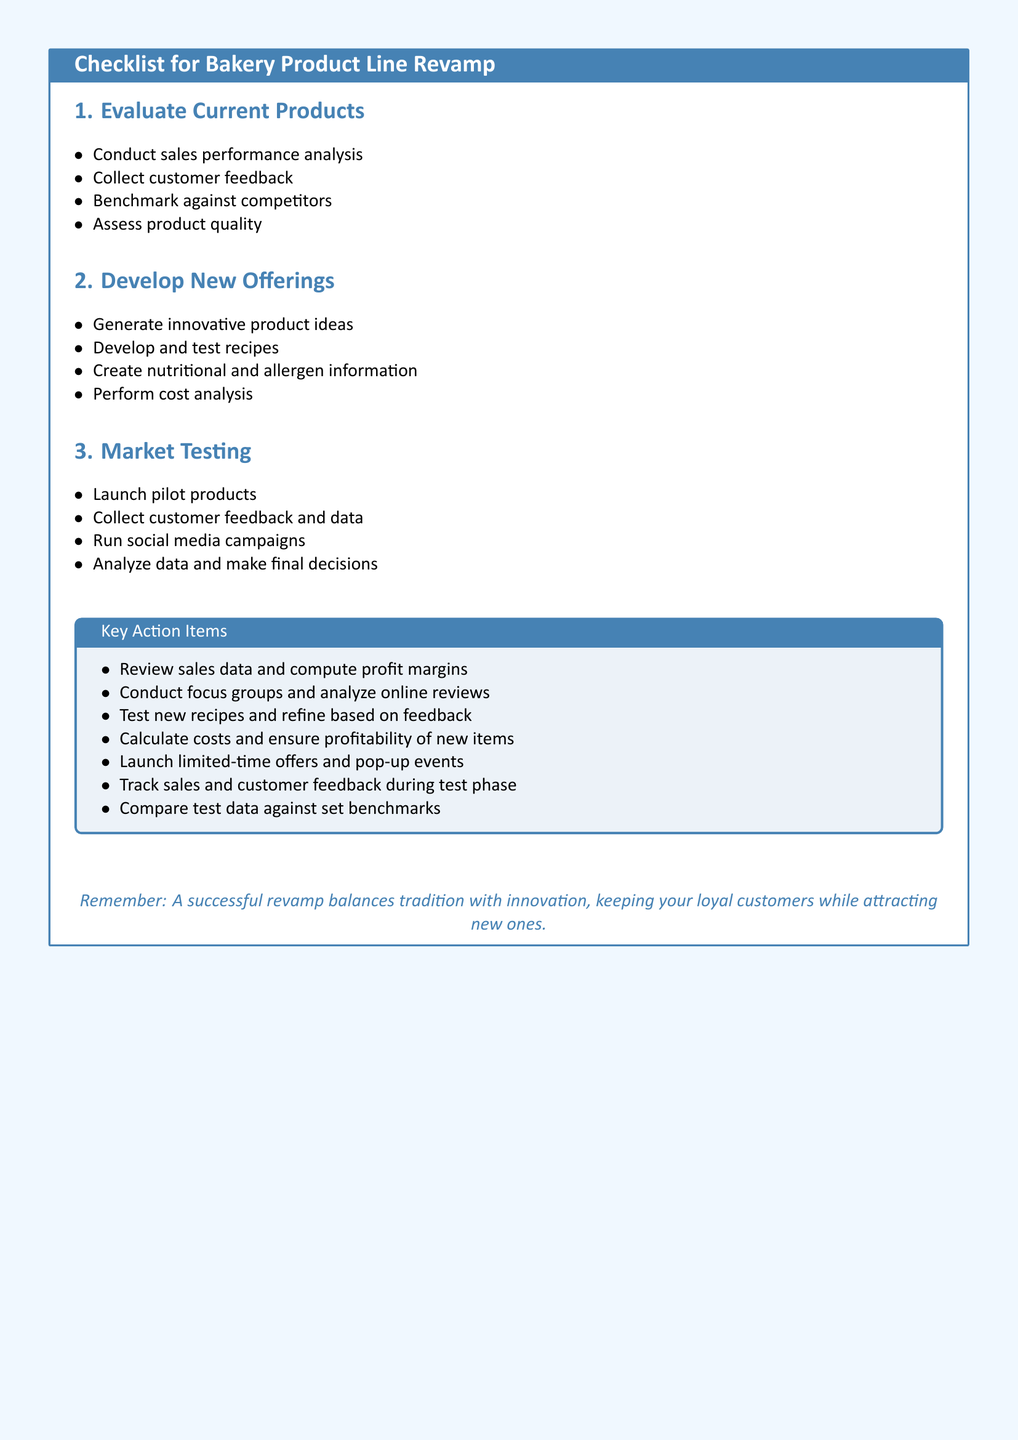What is the first section of the checklist? The first section outlines the evaluation of current products, which includes various tasks.
Answer: Evaluate Current Products What item suggests collecting feedback from customers? This is part of the first section focused on current product evaluation for insights.
Answer: Collect customer feedback How many items are listed under market testing? The market testing section provides a total of four distinct tasks for product evaluation.
Answer: Four What is the purpose of conducting a cost analysis? This is a critical step in the development of new offerings to ensure financial viability.
Answer: Ensure profitability What key action item emphasizes testing recipes? This action item is crucial for refining new product offerings based on received feedback.
Answer: Test new recipes and refine based on feedback What color is associated with the document’s theme? This color is used throughout the document for headings and important sections.
Answer: Bakery Blue 